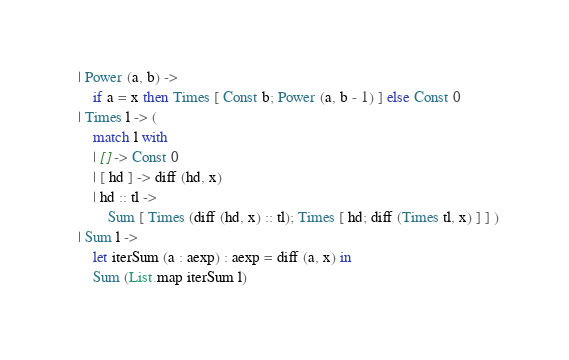<code> <loc_0><loc_0><loc_500><loc_500><_OCaml_>  | Power (a, b) ->
      if a = x then Times [ Const b; Power (a, b - 1) ] else Const 0
  | Times l -> (
      match l with
      | [] -> Const 0
      | [ hd ] -> diff (hd, x)
      | hd :: tl ->
          Sum [ Times (diff (hd, x) :: tl); Times [ hd; diff (Times tl, x) ] ] )
  | Sum l ->
      let iterSum (a : aexp) : aexp = diff (a, x) in
      Sum (List.map iterSum l)
</code> 